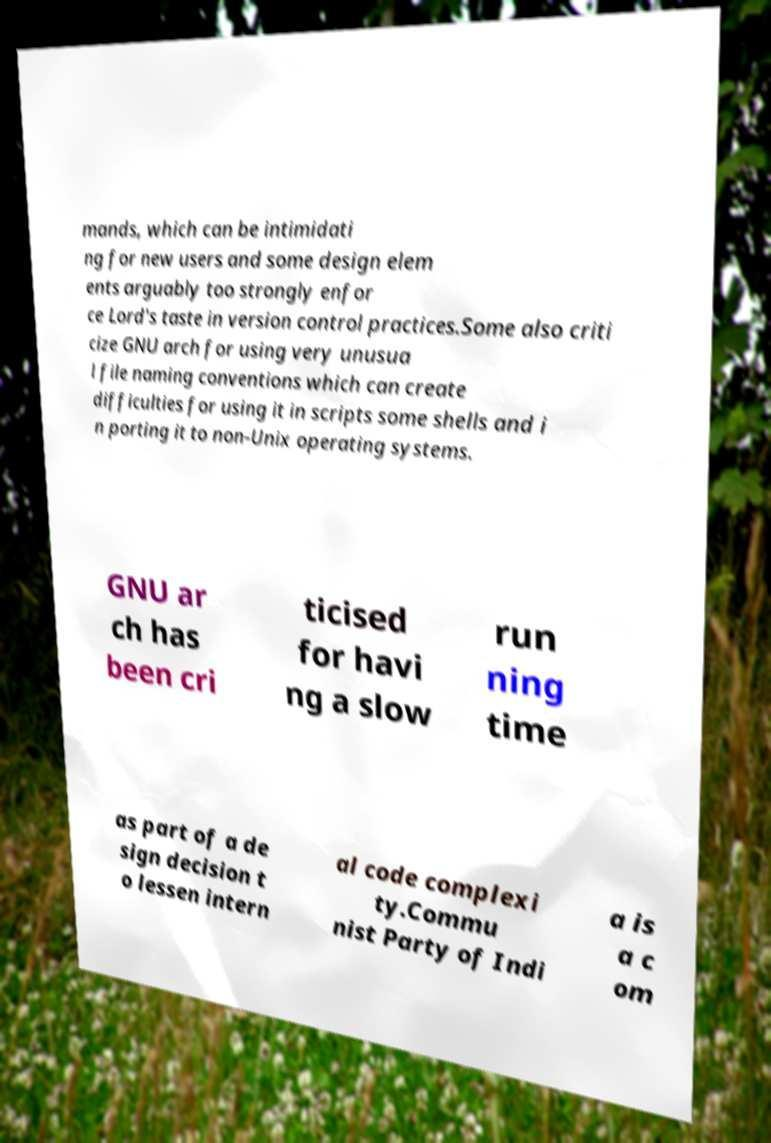Can you accurately transcribe the text from the provided image for me? mands, which can be intimidati ng for new users and some design elem ents arguably too strongly enfor ce Lord's taste in version control practices.Some also criti cize GNU arch for using very unusua l file naming conventions which can create difficulties for using it in scripts some shells and i n porting it to non-Unix operating systems. GNU ar ch has been cri ticised for havi ng a slow run ning time as part of a de sign decision t o lessen intern al code complexi ty.Commu nist Party of Indi a is a c om 